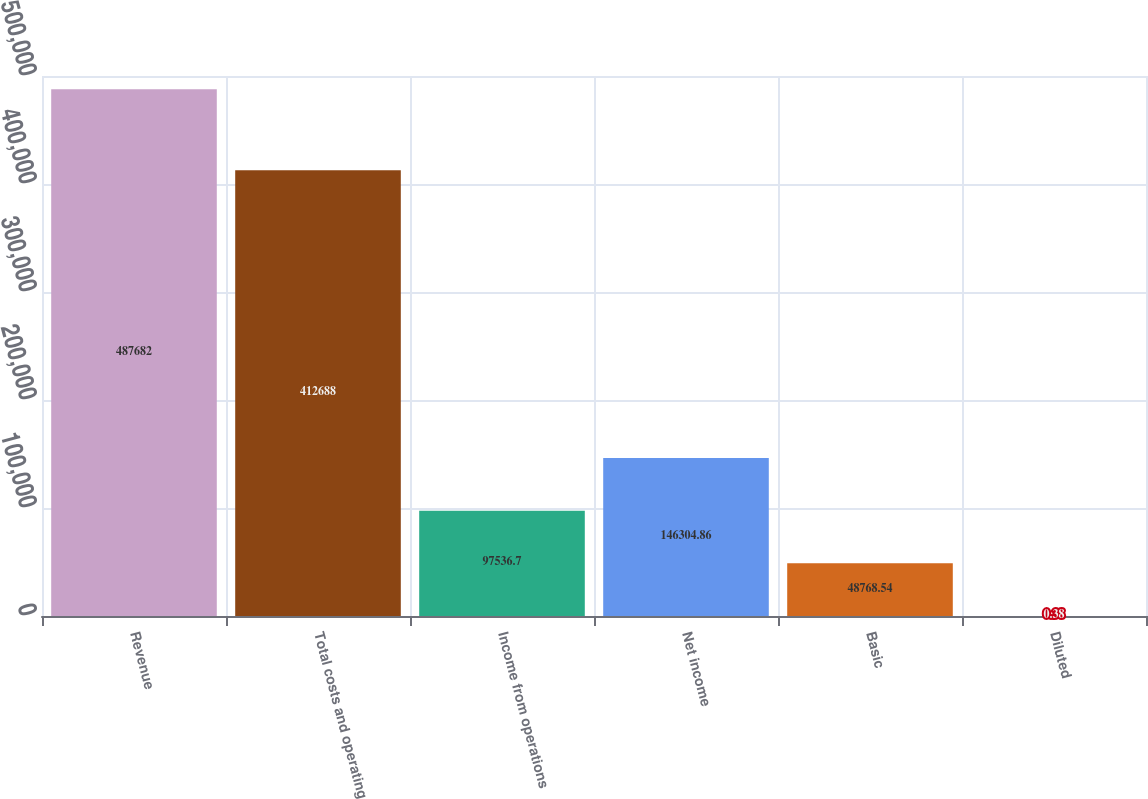Convert chart. <chart><loc_0><loc_0><loc_500><loc_500><bar_chart><fcel>Revenue<fcel>Total costs and operating<fcel>Income from operations<fcel>Net income<fcel>Basic<fcel>Diluted<nl><fcel>487682<fcel>412688<fcel>97536.7<fcel>146305<fcel>48768.5<fcel>0.38<nl></chart> 